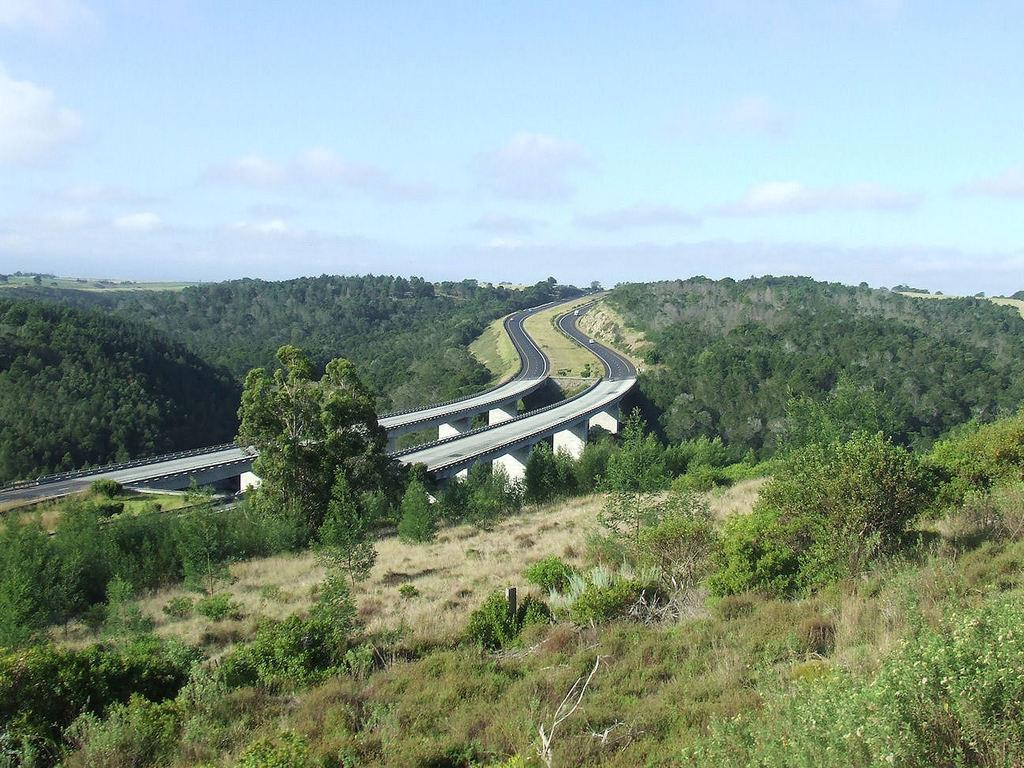What type of vegetation is present on the ground in the image? There is grass on the ground in the image. What other natural elements can be seen in the image? There are trees in the image. How would you describe the sky in the image? The sky is cloudy in the image. What type of man-made structures are visible in the image? There are roads in the center of the image. How many boats are visible in the image? There are no boats present in the image. What type of board is being used by the people in the image? There are no people or boards present in the image. 